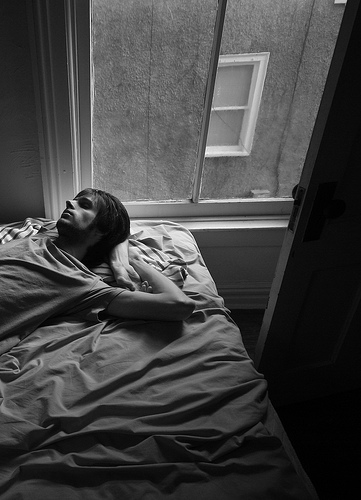Who is lying on the bed? A guy is lying on the bed. 